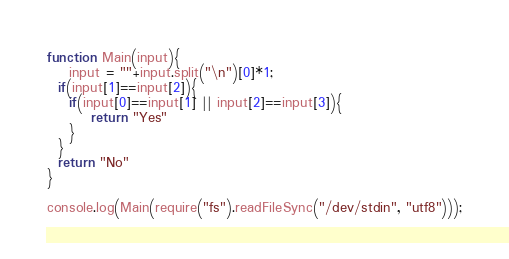<code> <loc_0><loc_0><loc_500><loc_500><_JavaScript_>function Main(input){
	input = ""+input.split("\n")[0]*1;
  if(input[1]==input[2]){
  	if(input[0]==input[1] || input[2]==input[3]){
    	return "Yes"
    }
  }
  return "No"
}

console.log(Main(require("fs").readFileSync("/dev/stdin", "utf8")));</code> 